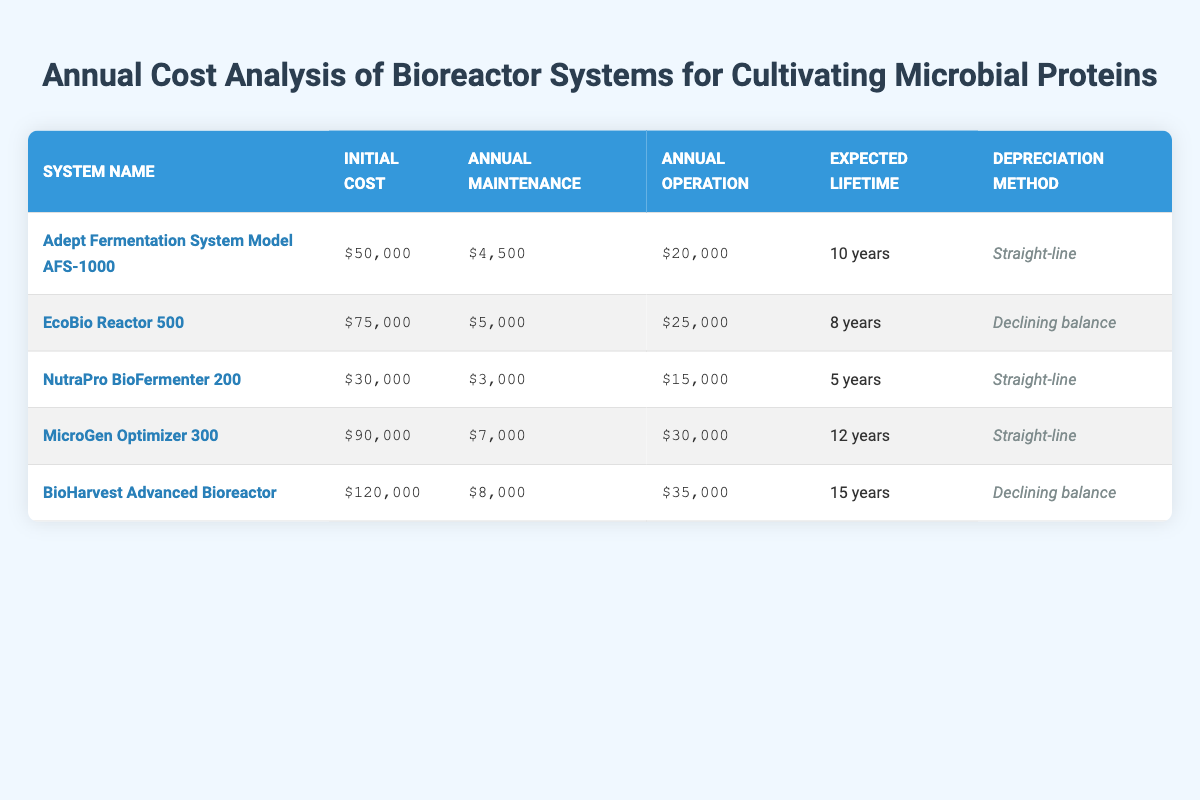What is the initial cost of the EcoBio Reactor 500? The initial cost is listed in the second row under the "Initial Cost" column for the EcoBio Reactor 500, which shows $75,000.
Answer: $75,000 Which bioreactor system has the highest annual operation cost? The annual operation cost can be compared by looking at the "Annual Operation" column. The BioHarvest Advanced Bioreactor has the highest cost at $35,000.
Answer: $35,000 What is the total expected lifetime of all the bioreactor systems combined? The expected lifetimes need to be summed up: 10 + 8 + 5 + 12 + 15 = 50 years.
Answer: 50 years Which bioreactor system has a straight-line depreciation method, and what is its initial cost? The table indicates that three systems use the straight-line depreciation method: AFS-1000 ($50,000), NutraPro BioFermenter 200 ($30,000), and MicroGen Optimizer 300 ($90,000).
Answer: AFS-1000: $50,000; NutraPro: $30,000; MicroGen: $90,000 Is the annual maintenance cost for the MicroGen Optimizer 300 greater than the operational cost of the NutraPro BioFermenter 200? The annual maintenance cost for MicroGen is $7,000, while the operational cost for NutraPro is $15,000. Since $7,000 is not greater than $15,000, the answer is no.
Answer: No How much more expensive is the initial cost of the BioHarvest Advanced Bioreactor compared to the NutraPro BioFermenter 200? To find the difference, subtract the initial cost of NutraPro ($30,000) from BioHarvest ($120,000): $120,000 - $30,000 = $90,000.
Answer: $90,000 What is the average annual maintenance cost across all bioreactor systems? The annual maintenance costs are: $4,500, $5,000, $3,000, $7,000, and $8,000. Summing these gives $27,500. Dividing by 5 (the number of systems), the average is $27,500 / 5 = $5,500.
Answer: $5,500 Is the operational cost of the EcoBio Reactor 500 lower than that of the MicroGen Optimizer 300? The operational cost of EcoBio is $25,000, and for MicroGen it is $30,000. Since $25,000 is less than $30,000, the answer is yes.
Answer: Yes Which bioreactor system has the longest expected lifetime, and how many years is that? Looking at the "Expected Lifetime" column, the BioHarvest Advanced Bioreactor shows a lifetime of 15 years, which is the longest.
Answer: BioHarvest Advanced Bioreactor; 15 years 